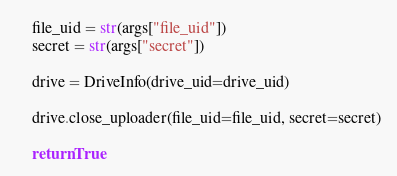<code> <loc_0><loc_0><loc_500><loc_500><_Python_>    file_uid = str(args["file_uid"])
    secret = str(args["secret"])

    drive = DriveInfo(drive_uid=drive_uid)

    drive.close_uploader(file_uid=file_uid, secret=secret)

    return True
</code> 